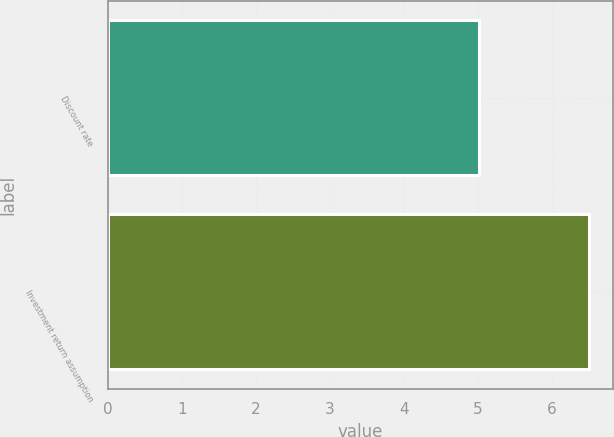Convert chart to OTSL. <chart><loc_0><loc_0><loc_500><loc_500><bar_chart><fcel>Discount rate<fcel>Investment return assumption<nl><fcel>5.01<fcel>6.5<nl></chart> 